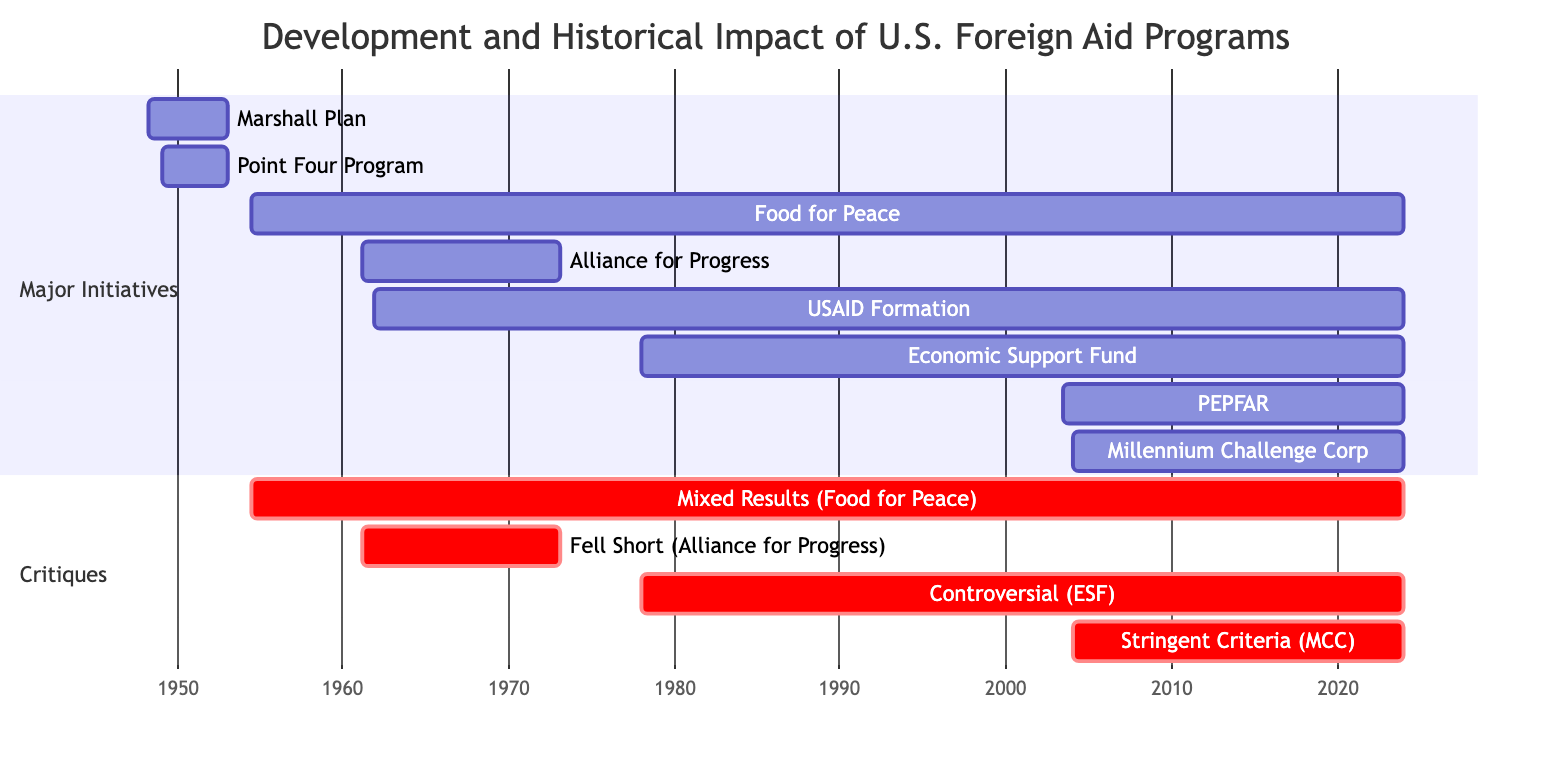What is the duration of the Marshall Plan? The Marshall Plan starts on April 3, 1948, and ends on December 31, 1952. To find the duration, calculate the difference between these two dates. The duration is from 1948 to 1952, which is approximately 4 years and 9 months.
Answer: 4 years 9 months Which program started in the year 1961? The diagram shows two programs starting in 1961: the Alliance for Progress on March 13 and USAID Formation on November 3. Both are clearly marked as starting in that year. Since the question asks for any program that started in 1961, both can be accepted as valid answers.
Answer: Alliance for Progress, USAID Formation How much money was allocated to the Point Four Program? The Point Four Program has a budget described as "Variable, project-specific." This indicates that there is no fixed budget amount and it depends on the specific projects.
Answer: Variable, project-specific Which aid program has been ongoing since 2003? The diagram mentions two aid programs that have been ongoing since 2003: PEPFAR, starting on May 27, and the Millennium Challenge Corporation, starting on January 23. Both programs are highlighted as ongoing initiatives within their respective timeframes.
Answer: PEPFAR, Millennium Challenge Corporation What is the total allocated amount of the Marshall Plan? The Marshall Plan's allocated amount is stated as "$13 billion." This figure is explicitly provided in the details of the program on the chart, making it a straightforward answer.
Answer: $13 billion Which foreign aid program had mixed results and is associated with U.S. agricultural interests? The Food for Peace program is clearly marked as having mixed results and is aimed at combating hunger while also promoting U.S. agricultural interests. Therefore, this program is the answer to the question.
Answer: Food for Peace What was the primary objective of the Millennium Challenge Corporation? The primary objective of the Millennium Challenge Corporation is stated as "Promote good governance, economic freedom, and investments in people." This goal is directly outlined in the program's details in the diagram.
Answer: Promote good governance, economic freedom, and investments in people In what year did the Economic Support Fund (ESF) begin? The Economic Support Fund (ESF) begins on January 1, 1978, as indicated in the timeline of the chart. The start date clearly marks the initiation of this program.
Answer: 1978 How many aid programs were initiated before 1960? The diagram shows three programs that started before the year 1960: the Marshall Plan (1948), the Point Four Program (1949), and Food for Peace (1954), which calculates to three total programs before 1960.
Answer: 3 